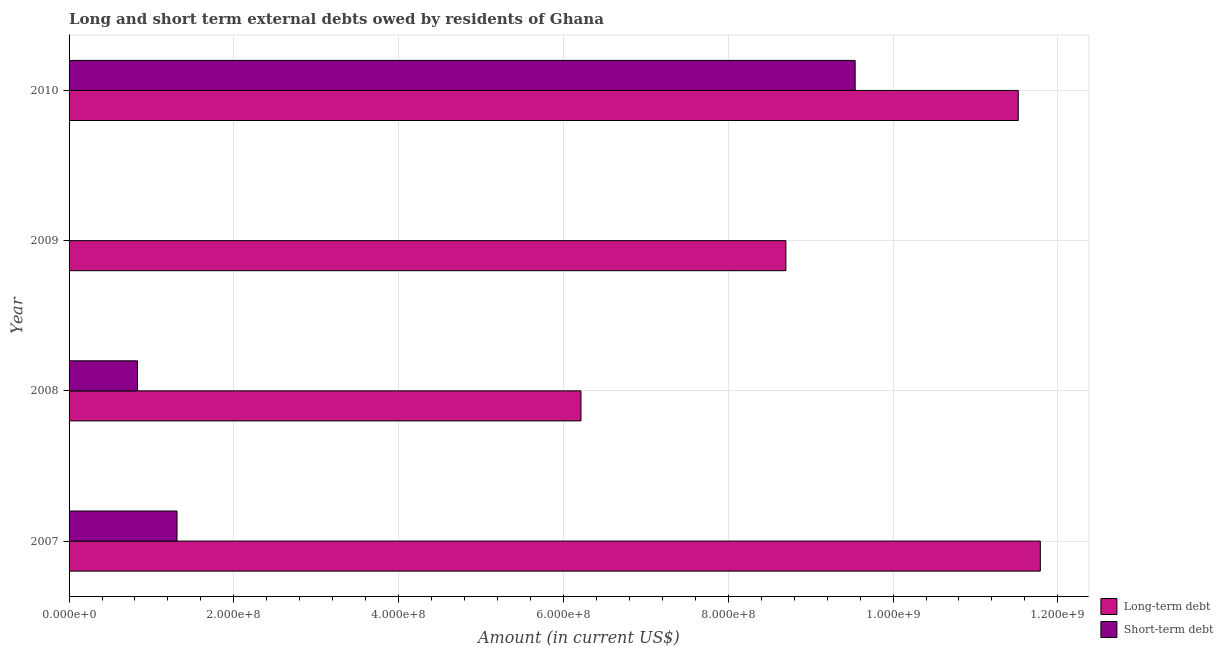How many different coloured bars are there?
Make the answer very short. 2. How many bars are there on the 1st tick from the top?
Give a very brief answer. 2. What is the label of the 3rd group of bars from the top?
Provide a succinct answer. 2008. What is the short-term debts owed by residents in 2007?
Offer a very short reply. 1.31e+08. Across all years, what is the maximum short-term debts owed by residents?
Offer a very short reply. 9.54e+08. Across all years, what is the minimum long-term debts owed by residents?
Your response must be concise. 6.21e+08. In which year was the long-term debts owed by residents maximum?
Offer a terse response. 2007. What is the total long-term debts owed by residents in the graph?
Your answer should be compact. 3.82e+09. What is the difference between the long-term debts owed by residents in 2007 and that in 2010?
Offer a very short reply. 2.68e+07. What is the difference between the long-term debts owed by residents in 2008 and the short-term debts owed by residents in 2007?
Your answer should be compact. 4.90e+08. What is the average long-term debts owed by residents per year?
Your answer should be compact. 9.55e+08. In the year 2007, what is the difference between the long-term debts owed by residents and short-term debts owed by residents?
Your answer should be very brief. 1.05e+09. What is the ratio of the long-term debts owed by residents in 2009 to that in 2010?
Offer a very short reply. 0.76. Is the short-term debts owed by residents in 2007 less than that in 2010?
Offer a terse response. Yes. What is the difference between the highest and the second highest short-term debts owed by residents?
Offer a terse response. 8.23e+08. What is the difference between the highest and the lowest short-term debts owed by residents?
Provide a short and direct response. 9.54e+08. Are all the bars in the graph horizontal?
Offer a terse response. Yes. What is the difference between two consecutive major ticks on the X-axis?
Your response must be concise. 2.00e+08. Are the values on the major ticks of X-axis written in scientific E-notation?
Offer a terse response. Yes. Where does the legend appear in the graph?
Keep it short and to the point. Bottom right. What is the title of the graph?
Your response must be concise. Long and short term external debts owed by residents of Ghana. What is the Amount (in current US$) in Long-term debt in 2007?
Offer a terse response. 1.18e+09. What is the Amount (in current US$) of Short-term debt in 2007?
Make the answer very short. 1.31e+08. What is the Amount (in current US$) of Long-term debt in 2008?
Offer a terse response. 6.21e+08. What is the Amount (in current US$) of Short-term debt in 2008?
Offer a very short reply. 8.30e+07. What is the Amount (in current US$) of Long-term debt in 2009?
Ensure brevity in your answer.  8.70e+08. What is the Amount (in current US$) of Short-term debt in 2009?
Make the answer very short. 0. What is the Amount (in current US$) of Long-term debt in 2010?
Offer a very short reply. 1.15e+09. What is the Amount (in current US$) of Short-term debt in 2010?
Keep it short and to the point. 9.54e+08. Across all years, what is the maximum Amount (in current US$) of Long-term debt?
Your response must be concise. 1.18e+09. Across all years, what is the maximum Amount (in current US$) in Short-term debt?
Make the answer very short. 9.54e+08. Across all years, what is the minimum Amount (in current US$) in Long-term debt?
Keep it short and to the point. 6.21e+08. What is the total Amount (in current US$) of Long-term debt in the graph?
Your response must be concise. 3.82e+09. What is the total Amount (in current US$) in Short-term debt in the graph?
Your response must be concise. 1.17e+09. What is the difference between the Amount (in current US$) of Long-term debt in 2007 and that in 2008?
Provide a short and direct response. 5.57e+08. What is the difference between the Amount (in current US$) in Short-term debt in 2007 and that in 2008?
Your answer should be very brief. 4.80e+07. What is the difference between the Amount (in current US$) of Long-term debt in 2007 and that in 2009?
Provide a succinct answer. 3.09e+08. What is the difference between the Amount (in current US$) in Long-term debt in 2007 and that in 2010?
Your response must be concise. 2.68e+07. What is the difference between the Amount (in current US$) of Short-term debt in 2007 and that in 2010?
Your answer should be very brief. -8.23e+08. What is the difference between the Amount (in current US$) in Long-term debt in 2008 and that in 2009?
Make the answer very short. -2.49e+08. What is the difference between the Amount (in current US$) in Long-term debt in 2008 and that in 2010?
Your answer should be compact. -5.31e+08. What is the difference between the Amount (in current US$) of Short-term debt in 2008 and that in 2010?
Your response must be concise. -8.71e+08. What is the difference between the Amount (in current US$) of Long-term debt in 2009 and that in 2010?
Provide a succinct answer. -2.82e+08. What is the difference between the Amount (in current US$) of Long-term debt in 2007 and the Amount (in current US$) of Short-term debt in 2008?
Offer a terse response. 1.10e+09. What is the difference between the Amount (in current US$) of Long-term debt in 2007 and the Amount (in current US$) of Short-term debt in 2010?
Your answer should be compact. 2.25e+08. What is the difference between the Amount (in current US$) in Long-term debt in 2008 and the Amount (in current US$) in Short-term debt in 2010?
Your response must be concise. -3.33e+08. What is the difference between the Amount (in current US$) in Long-term debt in 2009 and the Amount (in current US$) in Short-term debt in 2010?
Keep it short and to the point. -8.41e+07. What is the average Amount (in current US$) in Long-term debt per year?
Provide a succinct answer. 9.55e+08. What is the average Amount (in current US$) in Short-term debt per year?
Provide a succinct answer. 2.92e+08. In the year 2007, what is the difference between the Amount (in current US$) in Long-term debt and Amount (in current US$) in Short-term debt?
Your answer should be compact. 1.05e+09. In the year 2008, what is the difference between the Amount (in current US$) in Long-term debt and Amount (in current US$) in Short-term debt?
Your response must be concise. 5.38e+08. In the year 2010, what is the difference between the Amount (in current US$) in Long-term debt and Amount (in current US$) in Short-term debt?
Your answer should be very brief. 1.98e+08. What is the ratio of the Amount (in current US$) of Long-term debt in 2007 to that in 2008?
Offer a very short reply. 1.9. What is the ratio of the Amount (in current US$) of Short-term debt in 2007 to that in 2008?
Provide a succinct answer. 1.58. What is the ratio of the Amount (in current US$) of Long-term debt in 2007 to that in 2009?
Your answer should be very brief. 1.35. What is the ratio of the Amount (in current US$) of Long-term debt in 2007 to that in 2010?
Offer a very short reply. 1.02. What is the ratio of the Amount (in current US$) in Short-term debt in 2007 to that in 2010?
Give a very brief answer. 0.14. What is the ratio of the Amount (in current US$) of Long-term debt in 2008 to that in 2009?
Keep it short and to the point. 0.71. What is the ratio of the Amount (in current US$) of Long-term debt in 2008 to that in 2010?
Keep it short and to the point. 0.54. What is the ratio of the Amount (in current US$) of Short-term debt in 2008 to that in 2010?
Offer a very short reply. 0.09. What is the ratio of the Amount (in current US$) in Long-term debt in 2009 to that in 2010?
Provide a short and direct response. 0.76. What is the difference between the highest and the second highest Amount (in current US$) of Long-term debt?
Provide a succinct answer. 2.68e+07. What is the difference between the highest and the second highest Amount (in current US$) in Short-term debt?
Give a very brief answer. 8.23e+08. What is the difference between the highest and the lowest Amount (in current US$) of Long-term debt?
Your response must be concise. 5.57e+08. What is the difference between the highest and the lowest Amount (in current US$) of Short-term debt?
Offer a terse response. 9.54e+08. 